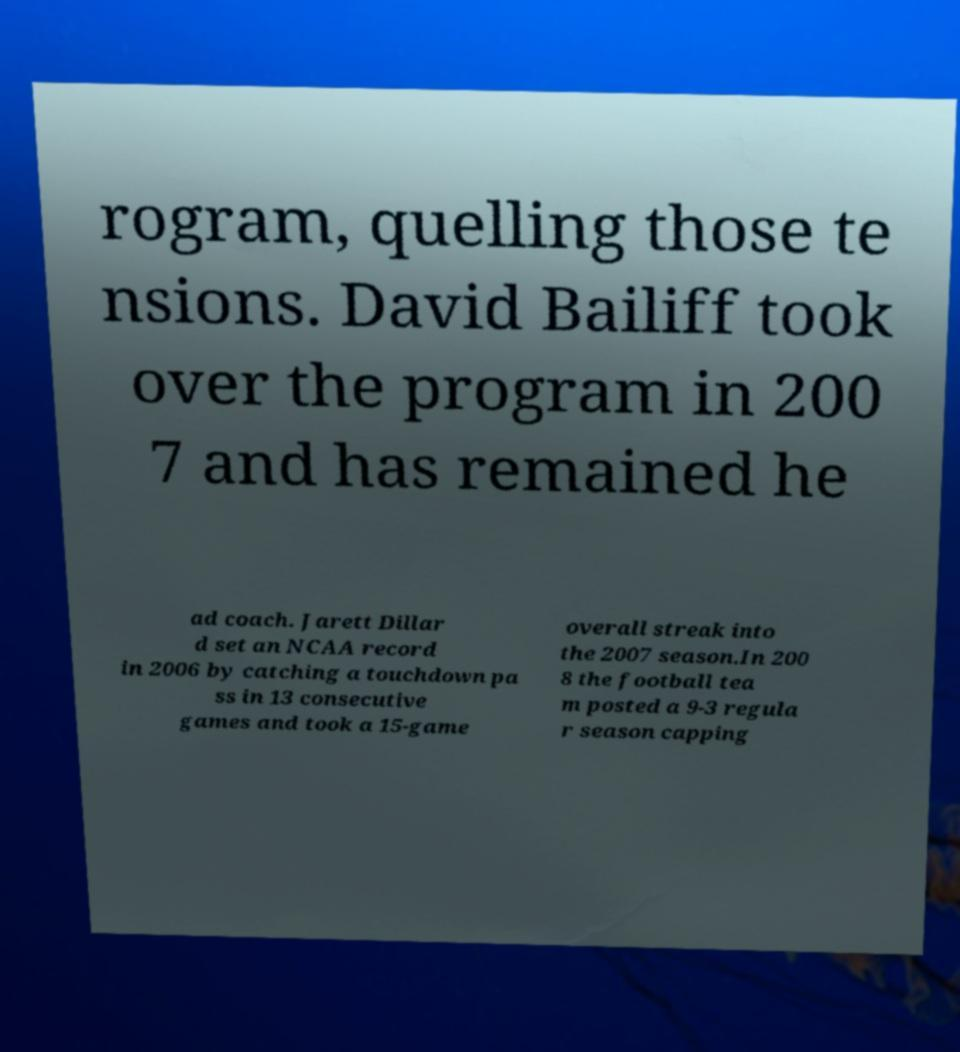Please read and relay the text visible in this image. What does it say? rogram, quelling those te nsions. David Bailiff took over the program in 200 7 and has remained he ad coach. Jarett Dillar d set an NCAA record in 2006 by catching a touchdown pa ss in 13 consecutive games and took a 15-game overall streak into the 2007 season.In 200 8 the football tea m posted a 9-3 regula r season capping 